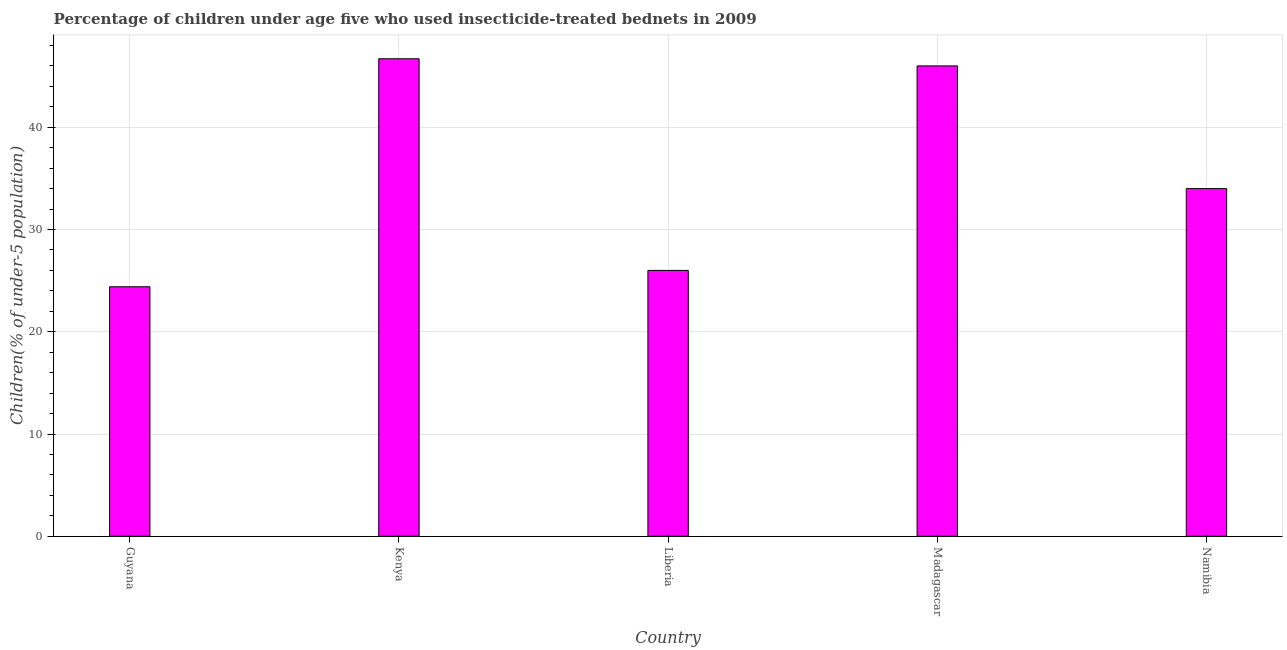Does the graph contain grids?
Keep it short and to the point. Yes. What is the title of the graph?
Make the answer very short. Percentage of children under age five who used insecticide-treated bednets in 2009. What is the label or title of the X-axis?
Your response must be concise. Country. What is the label or title of the Y-axis?
Keep it short and to the point. Children(% of under-5 population). What is the percentage of children who use of insecticide-treated bed nets in Guyana?
Make the answer very short. 24.4. Across all countries, what is the maximum percentage of children who use of insecticide-treated bed nets?
Give a very brief answer. 46.7. Across all countries, what is the minimum percentage of children who use of insecticide-treated bed nets?
Offer a terse response. 24.4. In which country was the percentage of children who use of insecticide-treated bed nets maximum?
Offer a terse response. Kenya. In which country was the percentage of children who use of insecticide-treated bed nets minimum?
Keep it short and to the point. Guyana. What is the sum of the percentage of children who use of insecticide-treated bed nets?
Your response must be concise. 177.1. What is the average percentage of children who use of insecticide-treated bed nets per country?
Your answer should be compact. 35.42. In how many countries, is the percentage of children who use of insecticide-treated bed nets greater than 4 %?
Your response must be concise. 5. What is the ratio of the percentage of children who use of insecticide-treated bed nets in Guyana to that in Liberia?
Offer a very short reply. 0.94. Is the percentage of children who use of insecticide-treated bed nets in Madagascar less than that in Namibia?
Your response must be concise. No. Is the difference between the percentage of children who use of insecticide-treated bed nets in Liberia and Madagascar greater than the difference between any two countries?
Your answer should be compact. No. What is the difference between the highest and the lowest percentage of children who use of insecticide-treated bed nets?
Keep it short and to the point. 22.3. In how many countries, is the percentage of children who use of insecticide-treated bed nets greater than the average percentage of children who use of insecticide-treated bed nets taken over all countries?
Make the answer very short. 2. How many bars are there?
Make the answer very short. 5. What is the Children(% of under-5 population) of Guyana?
Ensure brevity in your answer.  24.4. What is the Children(% of under-5 population) of Kenya?
Keep it short and to the point. 46.7. What is the Children(% of under-5 population) of Liberia?
Provide a succinct answer. 26. What is the difference between the Children(% of under-5 population) in Guyana and Kenya?
Give a very brief answer. -22.3. What is the difference between the Children(% of under-5 population) in Guyana and Madagascar?
Make the answer very short. -21.6. What is the difference between the Children(% of under-5 population) in Kenya and Liberia?
Your response must be concise. 20.7. What is the difference between the Children(% of under-5 population) in Kenya and Namibia?
Give a very brief answer. 12.7. What is the difference between the Children(% of under-5 population) in Liberia and Namibia?
Offer a terse response. -8. What is the difference between the Children(% of under-5 population) in Madagascar and Namibia?
Make the answer very short. 12. What is the ratio of the Children(% of under-5 population) in Guyana to that in Kenya?
Provide a succinct answer. 0.52. What is the ratio of the Children(% of under-5 population) in Guyana to that in Liberia?
Make the answer very short. 0.94. What is the ratio of the Children(% of under-5 population) in Guyana to that in Madagascar?
Ensure brevity in your answer.  0.53. What is the ratio of the Children(% of under-5 population) in Guyana to that in Namibia?
Give a very brief answer. 0.72. What is the ratio of the Children(% of under-5 population) in Kenya to that in Liberia?
Your answer should be very brief. 1.8. What is the ratio of the Children(% of under-5 population) in Kenya to that in Namibia?
Offer a terse response. 1.37. What is the ratio of the Children(% of under-5 population) in Liberia to that in Madagascar?
Offer a very short reply. 0.56. What is the ratio of the Children(% of under-5 population) in Liberia to that in Namibia?
Ensure brevity in your answer.  0.77. What is the ratio of the Children(% of under-5 population) in Madagascar to that in Namibia?
Ensure brevity in your answer.  1.35. 